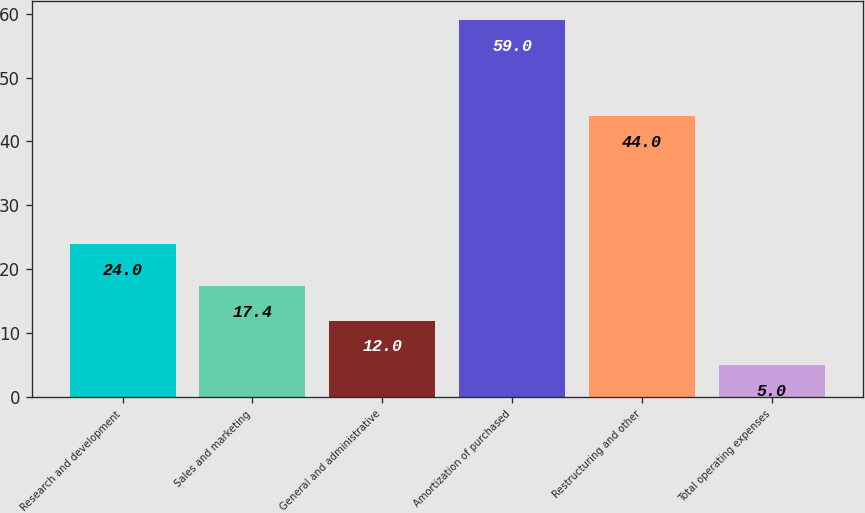Convert chart to OTSL. <chart><loc_0><loc_0><loc_500><loc_500><bar_chart><fcel>Research and development<fcel>Sales and marketing<fcel>General and administrative<fcel>Amortization of purchased<fcel>Restructuring and other<fcel>Total operating expenses<nl><fcel>24<fcel>17.4<fcel>12<fcel>59<fcel>44<fcel>5<nl></chart> 